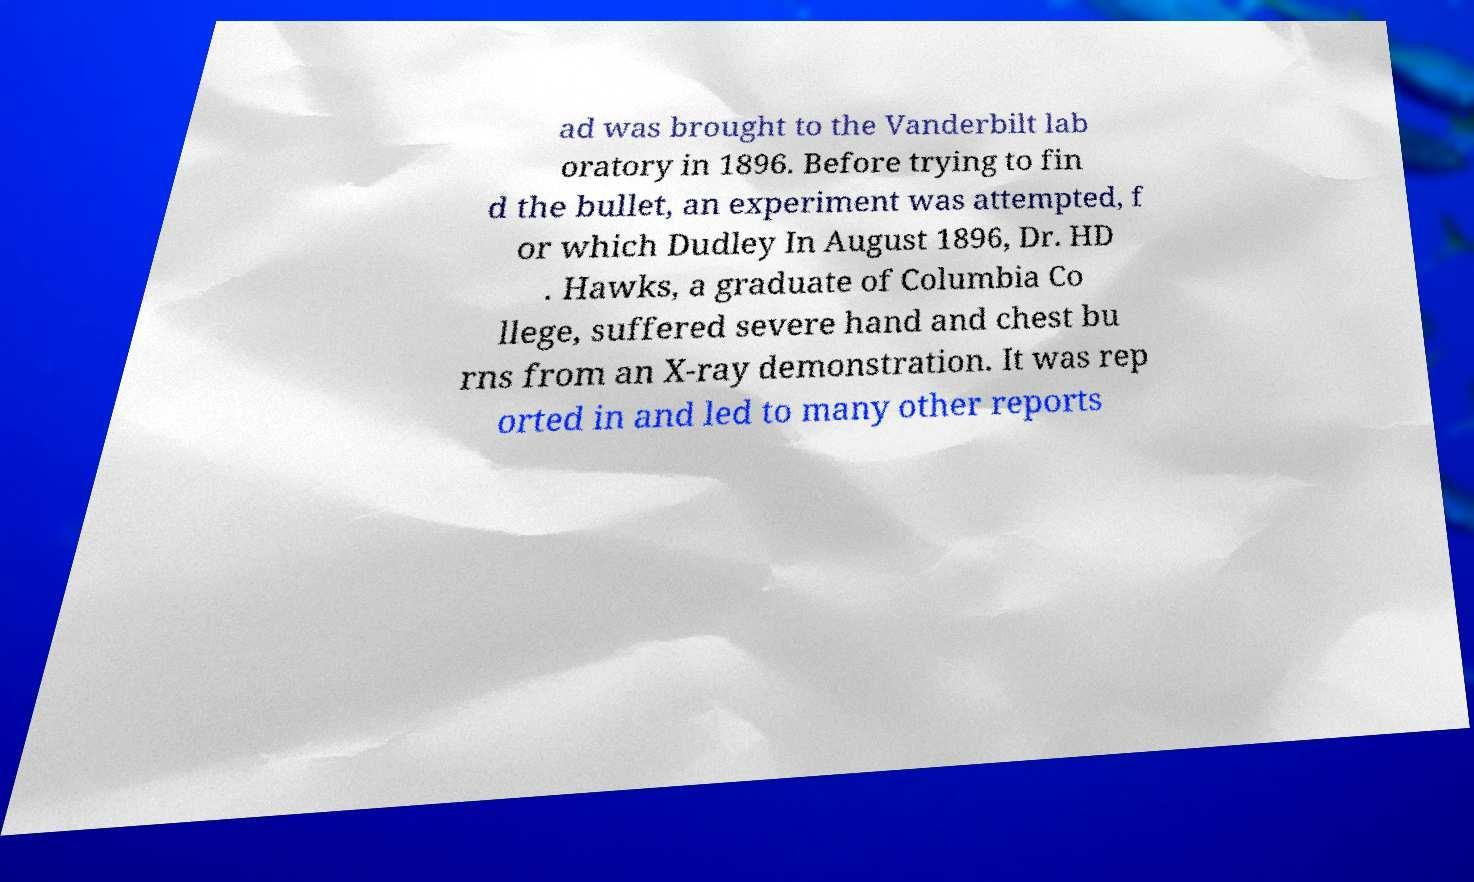For documentation purposes, I need the text within this image transcribed. Could you provide that? ad was brought to the Vanderbilt lab oratory in 1896. Before trying to fin d the bullet, an experiment was attempted, f or which Dudley In August 1896, Dr. HD . Hawks, a graduate of Columbia Co llege, suffered severe hand and chest bu rns from an X-ray demonstration. It was rep orted in and led to many other reports 